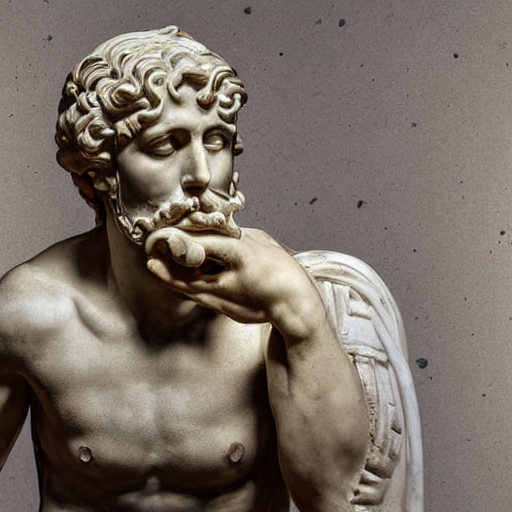Could you tell me about the historical significance of statues like this? Certainly. Statues like this were typically created to represent gods, heroes, or important figures from mythology and history. They are significant markers of cultural values and aesthetics of the time, reflecting the society's ideals of beauty and heroism. Do characteristics of the statue provide clues to its possible identity? Yes, the facial hair, the headband, and the contemplative pose are indicative of a figure from mythology or literature, such as a philosopher or deity. These attributes were commonly used to convey wisdom and nobility in historical representations. 